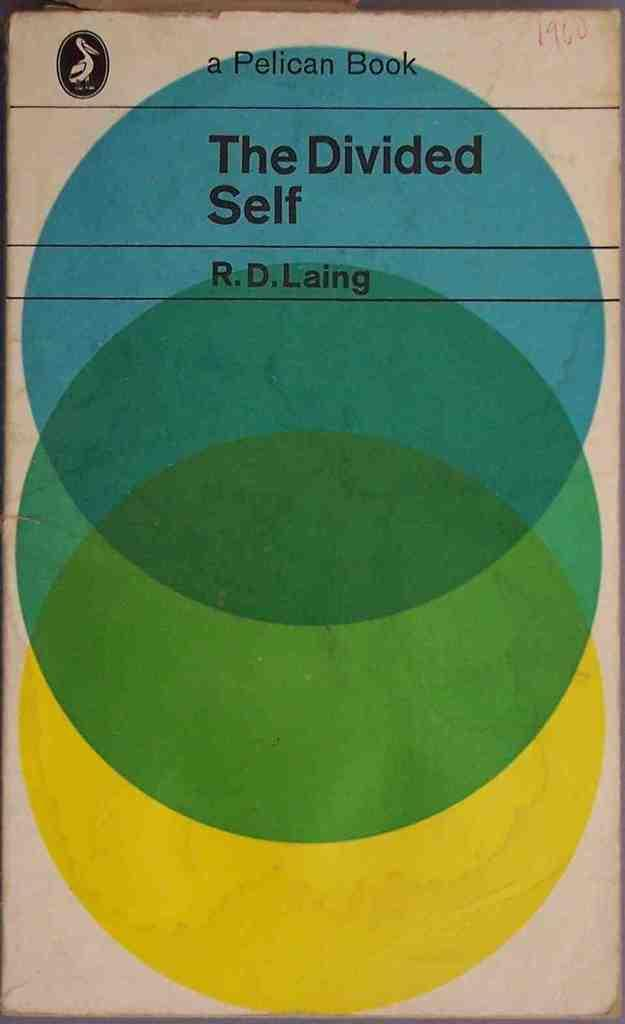<image>
Share a concise interpretation of the image provided. Book with three circles on it titled "The Divided Self". 